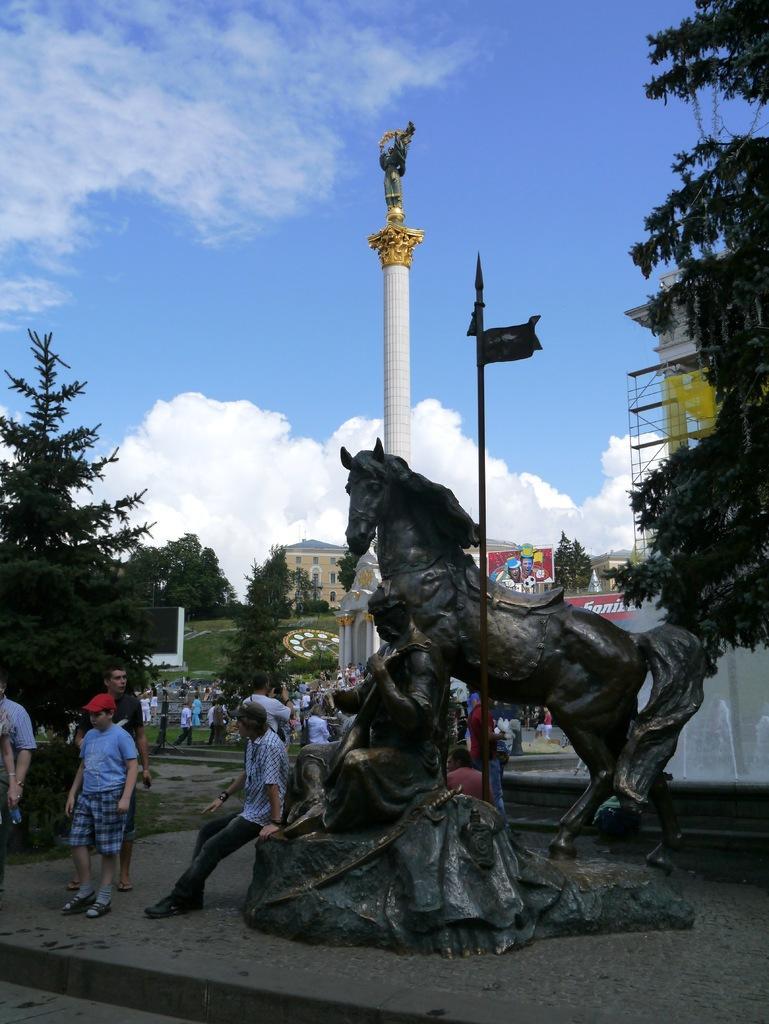How would you summarize this image in a sentence or two? In this picture we can see a statue and group of people, in the background we can find few trees, a tower, buildings and clouds. 